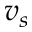<formula> <loc_0><loc_0><loc_500><loc_500>v _ { s }</formula> 